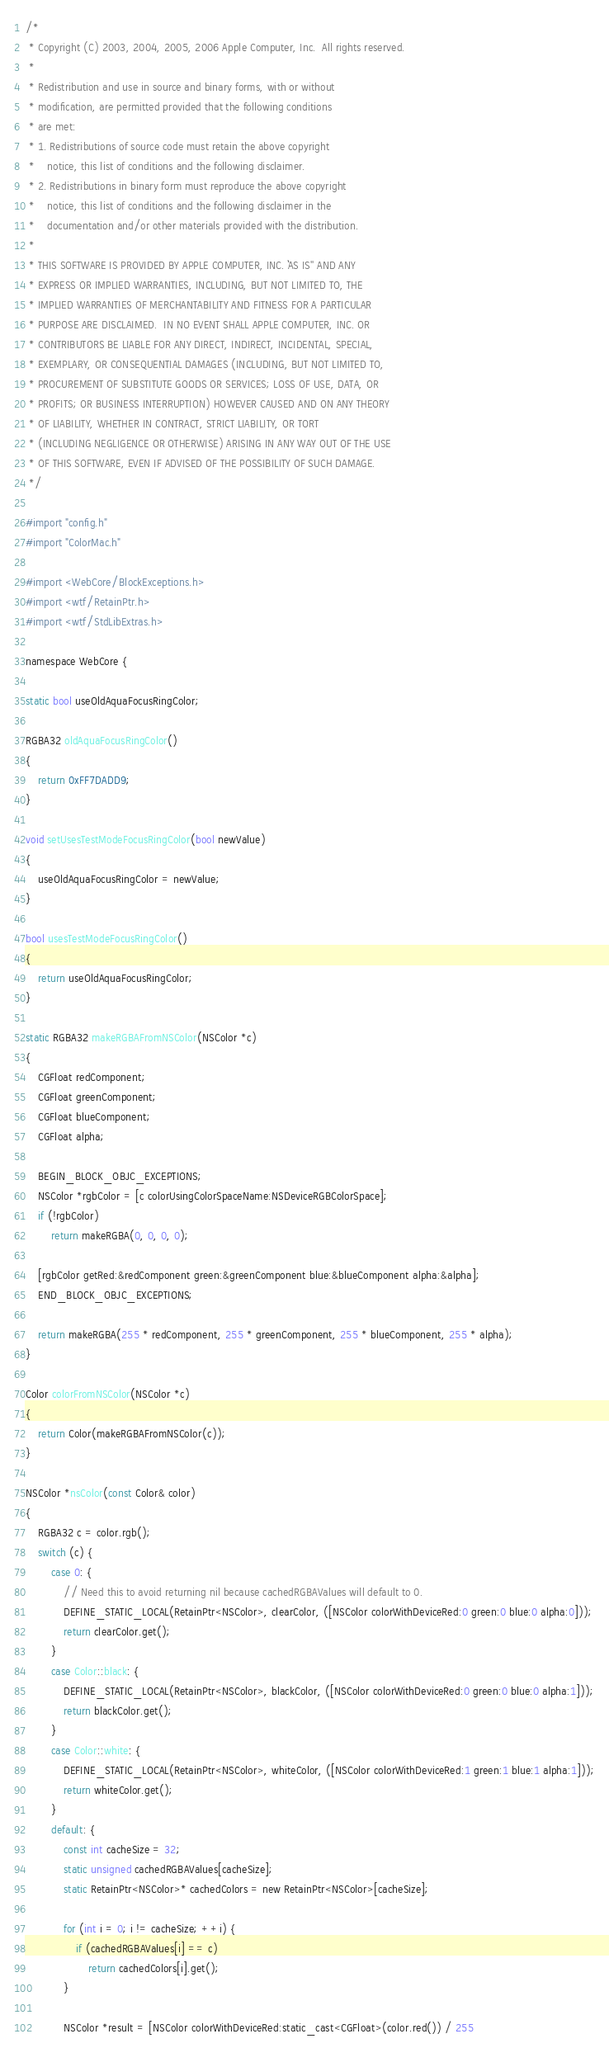<code> <loc_0><loc_0><loc_500><loc_500><_ObjectiveC_>/*
 * Copyright (C) 2003, 2004, 2005, 2006 Apple Computer, Inc.  All rights reserved.
 *
 * Redistribution and use in source and binary forms, with or without
 * modification, are permitted provided that the following conditions
 * are met:
 * 1. Redistributions of source code must retain the above copyright
 *    notice, this list of conditions and the following disclaimer.
 * 2. Redistributions in binary form must reproduce the above copyright
 *    notice, this list of conditions and the following disclaimer in the
 *    documentation and/or other materials provided with the distribution.
 *
 * THIS SOFTWARE IS PROVIDED BY APPLE COMPUTER, INC. ``AS IS'' AND ANY
 * EXPRESS OR IMPLIED WARRANTIES, INCLUDING, BUT NOT LIMITED TO, THE
 * IMPLIED WARRANTIES OF MERCHANTABILITY AND FITNESS FOR A PARTICULAR
 * PURPOSE ARE DISCLAIMED.  IN NO EVENT SHALL APPLE COMPUTER, INC. OR
 * CONTRIBUTORS BE LIABLE FOR ANY DIRECT, INDIRECT, INCIDENTAL, SPECIAL,
 * EXEMPLARY, OR CONSEQUENTIAL DAMAGES (INCLUDING, BUT NOT LIMITED TO,
 * PROCUREMENT OF SUBSTITUTE GOODS OR SERVICES; LOSS OF USE, DATA, OR
 * PROFITS; OR BUSINESS INTERRUPTION) HOWEVER CAUSED AND ON ANY THEORY
 * OF LIABILITY, WHETHER IN CONTRACT, STRICT LIABILITY, OR TORT
 * (INCLUDING NEGLIGENCE OR OTHERWISE) ARISING IN ANY WAY OUT OF THE USE
 * OF THIS SOFTWARE, EVEN IF ADVISED OF THE POSSIBILITY OF SUCH DAMAGE. 
 */

#import "config.h"
#import "ColorMac.h"

#import <WebCore/BlockExceptions.h>
#import <wtf/RetainPtr.h>
#import <wtf/StdLibExtras.h>

namespace WebCore {

static bool useOldAquaFocusRingColor;

RGBA32 oldAquaFocusRingColor()
{
    return 0xFF7DADD9;
}

void setUsesTestModeFocusRingColor(bool newValue)
{
    useOldAquaFocusRingColor = newValue;
}

bool usesTestModeFocusRingColor()
{
    return useOldAquaFocusRingColor;
}

static RGBA32 makeRGBAFromNSColor(NSColor *c)
{
    CGFloat redComponent;
    CGFloat greenComponent;
    CGFloat blueComponent;
    CGFloat alpha;

    BEGIN_BLOCK_OBJC_EXCEPTIONS;
    NSColor *rgbColor = [c colorUsingColorSpaceName:NSDeviceRGBColorSpace];
    if (!rgbColor)
        return makeRGBA(0, 0, 0, 0);

    [rgbColor getRed:&redComponent green:&greenComponent blue:&blueComponent alpha:&alpha];
    END_BLOCK_OBJC_EXCEPTIONS;

    return makeRGBA(255 * redComponent, 255 * greenComponent, 255 * blueComponent, 255 * alpha);
}

Color colorFromNSColor(NSColor *c)
{
    return Color(makeRGBAFromNSColor(c));
}

NSColor *nsColor(const Color& color)
{
    RGBA32 c = color.rgb();
    switch (c) {
        case 0: {
            // Need this to avoid returning nil because cachedRGBAValues will default to 0.
            DEFINE_STATIC_LOCAL(RetainPtr<NSColor>, clearColor, ([NSColor colorWithDeviceRed:0 green:0 blue:0 alpha:0]));
            return clearColor.get();
        }
        case Color::black: {
            DEFINE_STATIC_LOCAL(RetainPtr<NSColor>, blackColor, ([NSColor colorWithDeviceRed:0 green:0 blue:0 alpha:1]));
            return blackColor.get();
        }
        case Color::white: {
            DEFINE_STATIC_LOCAL(RetainPtr<NSColor>, whiteColor, ([NSColor colorWithDeviceRed:1 green:1 blue:1 alpha:1]));
            return whiteColor.get();
        }
        default: {
            const int cacheSize = 32;
            static unsigned cachedRGBAValues[cacheSize];
            static RetainPtr<NSColor>* cachedColors = new RetainPtr<NSColor>[cacheSize];

            for (int i = 0; i != cacheSize; ++i) {
                if (cachedRGBAValues[i] == c)
                    return cachedColors[i].get();
            }

            NSColor *result = [NSColor colorWithDeviceRed:static_cast<CGFloat>(color.red()) / 255</code> 